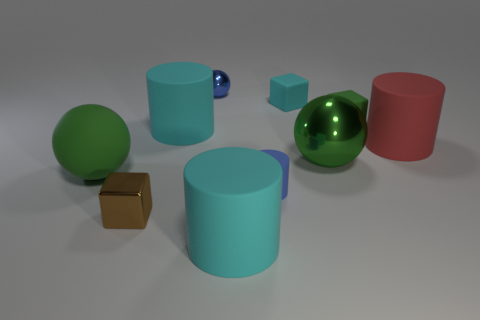What kind of lighting is used in this setup and how does it affect the objects? The scene seems to be lit with a soft overhead light, creating subtle shadows under the objects and gentle highlights on their surfaces, particularly noticeable on the glossy sphere and metal cube. Is there a predominant color theme in this image? Yes, there is a predominance of blue-green hues, known as cyan, in various shades and tones on the objects. 